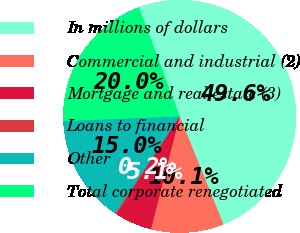Convert chart. <chart><loc_0><loc_0><loc_500><loc_500><pie_chart><fcel>In millions of dollars<fcel>Commercial and industrial (2)<fcel>Mortgage and real estate (3)<fcel>Loans to financial<fcel>Other<fcel>Total corporate renegotiated<nl><fcel>49.56%<fcel>10.09%<fcel>5.15%<fcel>0.22%<fcel>15.02%<fcel>19.96%<nl></chart> 